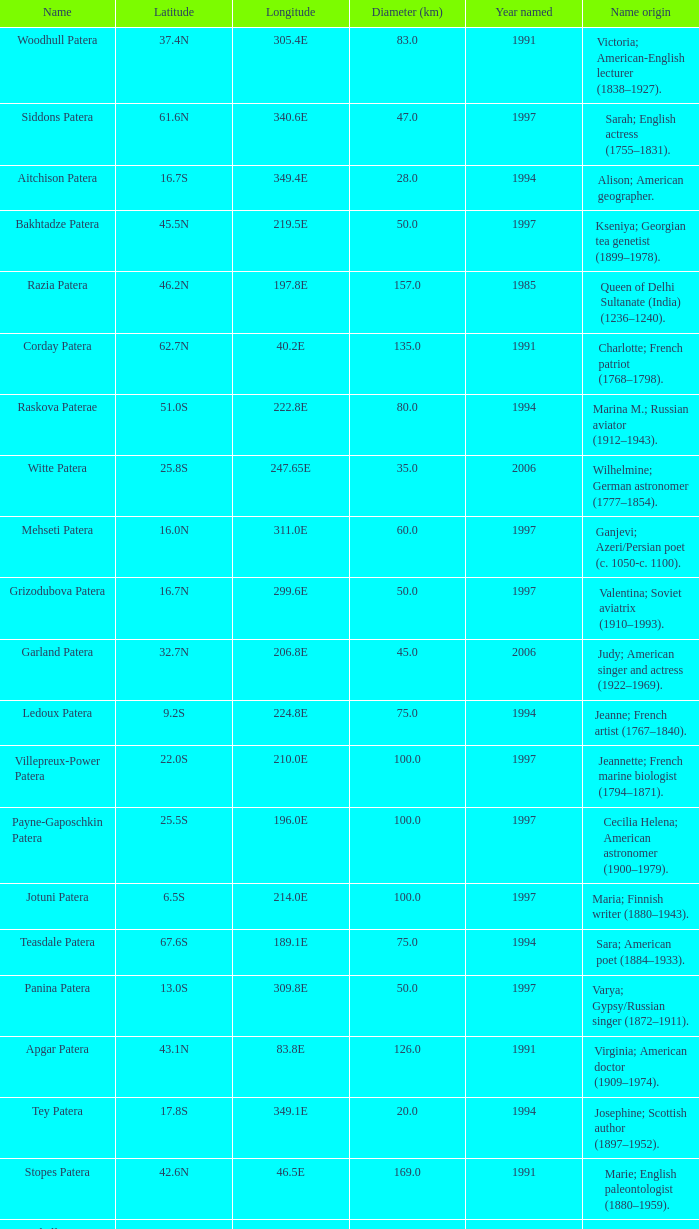What is  the diameter in km of the feature with a longitude of 40.2E?  135.0. 